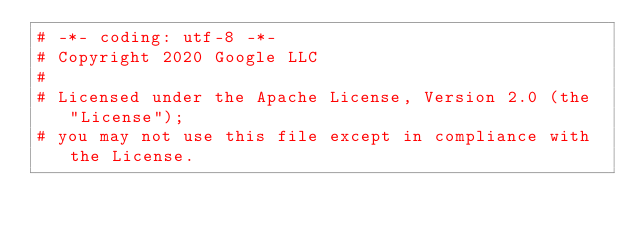<code> <loc_0><loc_0><loc_500><loc_500><_Python_># -*- coding: utf-8 -*-
# Copyright 2020 Google LLC
#
# Licensed under the Apache License, Version 2.0 (the "License");
# you may not use this file except in compliance with the License.</code> 